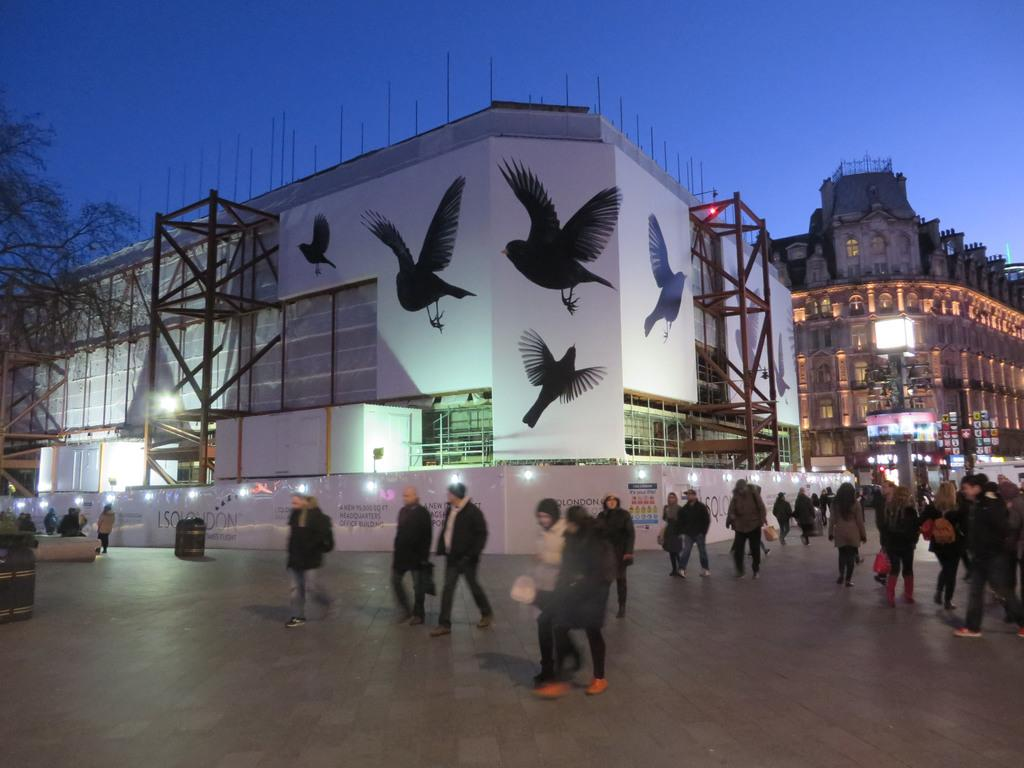What are the people in the image doing? The people in the image are walking on the floor. What is the main structure in the image? There is a building in the middle of the image. What decorative elements are present on the building? The building has drawings of birds on it. What type of vegetation can be seen on the left side of the image? There appears to be a tree on the left side of the image. What type of wave can be seen crashing against the building in the image? There is no wave present in the image; it features people walking, a building with bird drawings, and a tree. What is the zinc content of the tree on the left side of the image? There is no information about the zinc content of the tree in the image, as it is not relevant to the image's content. 